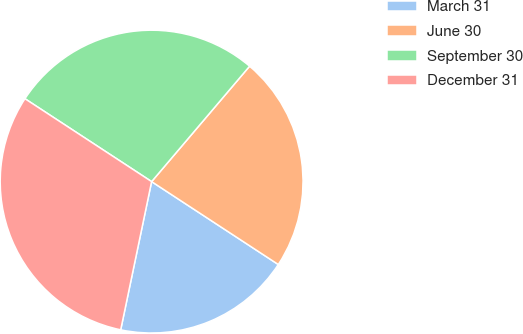Convert chart. <chart><loc_0><loc_0><loc_500><loc_500><pie_chart><fcel>March 31<fcel>June 30<fcel>September 30<fcel>December 31<nl><fcel>19.05%<fcel>23.02%<fcel>26.98%<fcel>30.95%<nl></chart> 